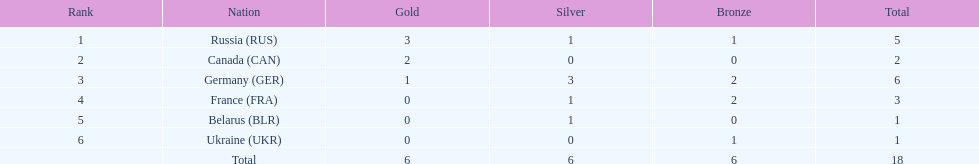How many silver medals did belarus win? 1. Would you mind parsing the complete table? {'header': ['Rank', 'Nation', 'Gold', 'Silver', 'Bronze', 'Total'], 'rows': [['1', 'Russia\xa0(RUS)', '3', '1', '1', '5'], ['2', 'Canada\xa0(CAN)', '2', '0', '0', '2'], ['3', 'Germany\xa0(GER)', '1', '3', '2', '6'], ['4', 'France\xa0(FRA)', '0', '1', '2', '3'], ['5', 'Belarus\xa0(BLR)', '0', '1', '0', '1'], ['6', 'Ukraine\xa0(UKR)', '0', '0', '1', '1'], ['', 'Total', '6', '6', '6', '18']]} 